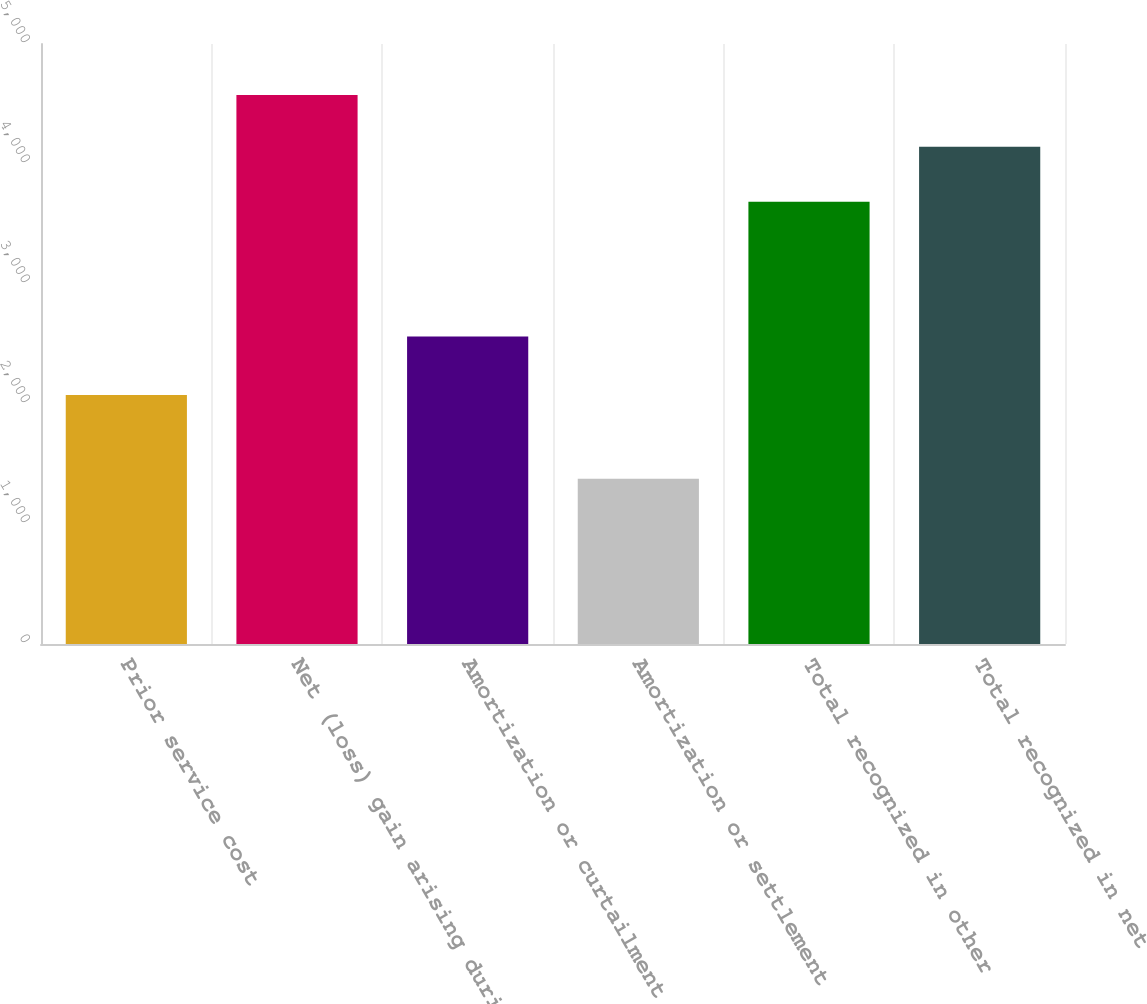Convert chart. <chart><loc_0><loc_0><loc_500><loc_500><bar_chart><fcel>Prior service cost<fcel>Net (loss) gain arising during<fcel>Amortization or curtailment<fcel>Amortization or settlement<fcel>Total recognized in other<fcel>Total recognized in net<nl><fcel>2074<fcel>4574<fcel>2563<fcel>1378<fcel>3685<fcel>4144<nl></chart> 